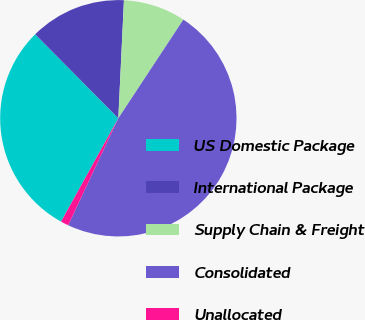Convert chart. <chart><loc_0><loc_0><loc_500><loc_500><pie_chart><fcel>US Domestic Package<fcel>International Package<fcel>Supply Chain & Freight<fcel>Consolidated<fcel>Unallocated<nl><fcel>29.52%<fcel>13.18%<fcel>8.52%<fcel>47.7%<fcel>1.08%<nl></chart> 